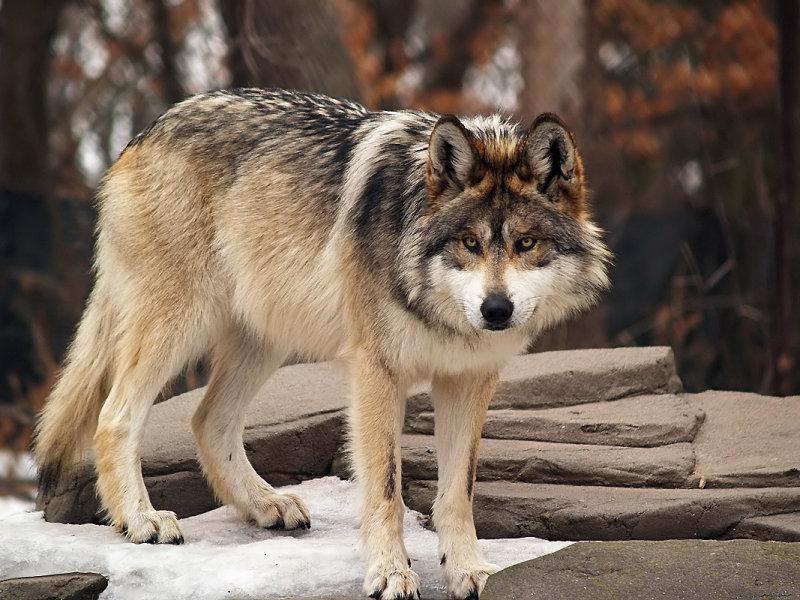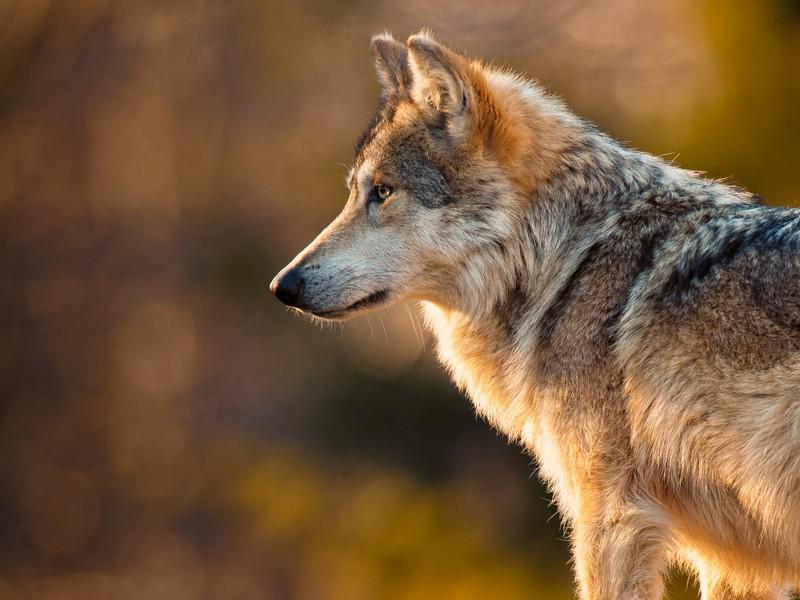The first image is the image on the left, the second image is the image on the right. For the images shown, is this caption "Each image contains exactly one wolf, and the righthand wolf faces leftward." true? Answer yes or no. Yes. The first image is the image on the left, the second image is the image on the right. Examine the images to the left and right. Is the description "The wolf in the right image is facing towards the left." accurate? Answer yes or no. Yes. 